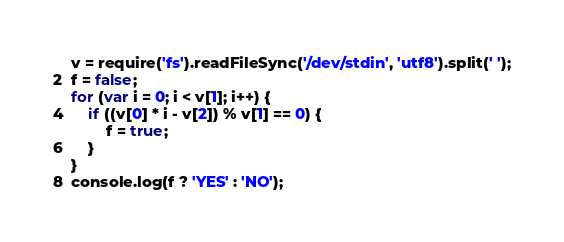Convert code to text. <code><loc_0><loc_0><loc_500><loc_500><_JavaScript_>v = require('fs').readFileSync('/dev/stdin', 'utf8').split(' ');
f = false;
for (var i = 0; i < v[1]; i++) {
    if ((v[0] * i - v[2]) % v[1] == 0) {
        f = true;
    }
}
console.log(f ? 'YES' : 'NO');</code> 